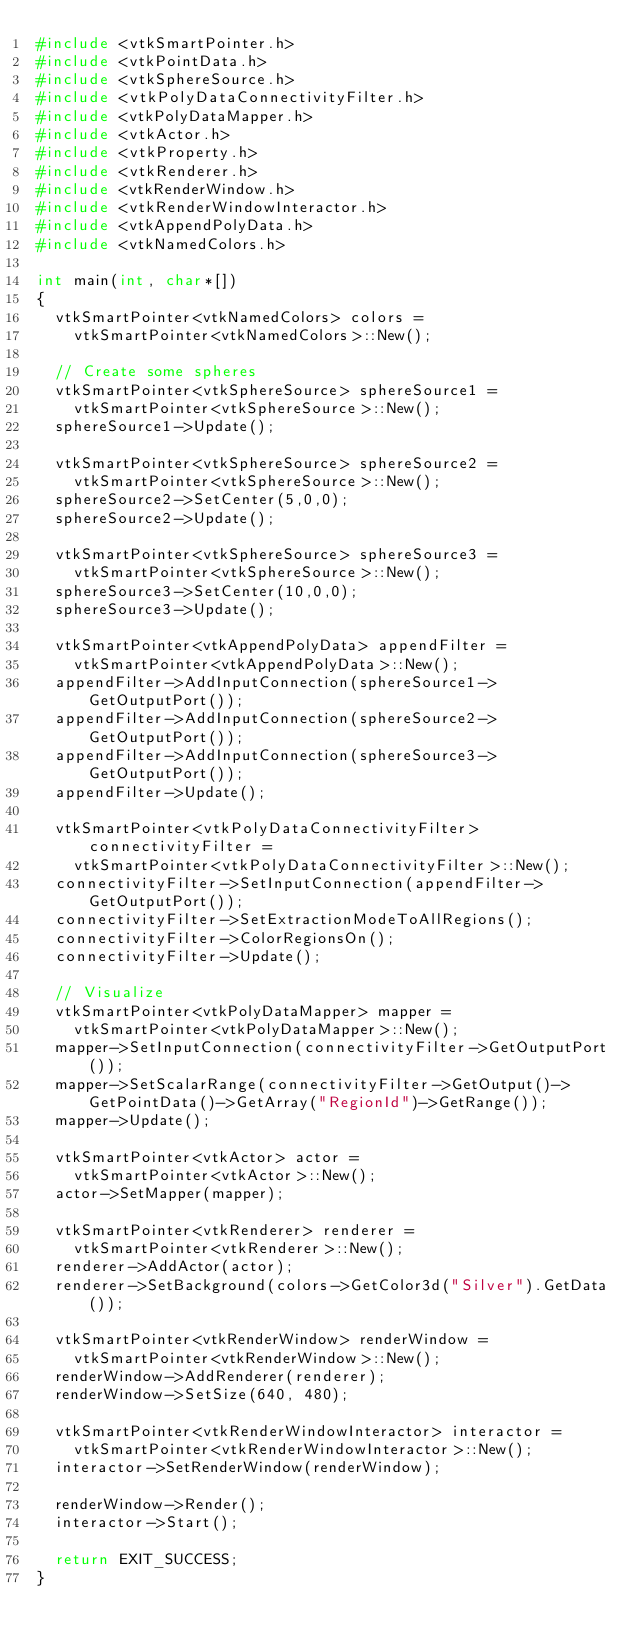Convert code to text. <code><loc_0><loc_0><loc_500><loc_500><_C++_>#include <vtkSmartPointer.h>
#include <vtkPointData.h>
#include <vtkSphereSource.h>
#include <vtkPolyDataConnectivityFilter.h>
#include <vtkPolyDataMapper.h>
#include <vtkActor.h>
#include <vtkProperty.h>
#include <vtkRenderer.h>
#include <vtkRenderWindow.h>
#include <vtkRenderWindowInteractor.h>
#include <vtkAppendPolyData.h>
#include <vtkNamedColors.h>

int main(int, char*[])
{
  vtkSmartPointer<vtkNamedColors> colors =
    vtkSmartPointer<vtkNamedColors>::New();

  // Create some spheres
  vtkSmartPointer<vtkSphereSource> sphereSource1 =
    vtkSmartPointer<vtkSphereSource>::New();
  sphereSource1->Update();

  vtkSmartPointer<vtkSphereSource> sphereSource2 =
    vtkSmartPointer<vtkSphereSource>::New();
  sphereSource2->SetCenter(5,0,0);
  sphereSource2->Update();

  vtkSmartPointer<vtkSphereSource> sphereSource3 =
    vtkSmartPointer<vtkSphereSource>::New();
  sphereSource3->SetCenter(10,0,0);
  sphereSource3->Update();

  vtkSmartPointer<vtkAppendPolyData> appendFilter =
    vtkSmartPointer<vtkAppendPolyData>::New();
  appendFilter->AddInputConnection(sphereSource1->GetOutputPort());
  appendFilter->AddInputConnection(sphereSource2->GetOutputPort());
  appendFilter->AddInputConnection(sphereSource3->GetOutputPort());
  appendFilter->Update();

  vtkSmartPointer<vtkPolyDataConnectivityFilter> connectivityFilter =
    vtkSmartPointer<vtkPolyDataConnectivityFilter>::New();
  connectivityFilter->SetInputConnection(appendFilter->GetOutputPort());
  connectivityFilter->SetExtractionModeToAllRegions();
  connectivityFilter->ColorRegionsOn();
  connectivityFilter->Update();

  // Visualize
  vtkSmartPointer<vtkPolyDataMapper> mapper =
    vtkSmartPointer<vtkPolyDataMapper>::New();
  mapper->SetInputConnection(connectivityFilter->GetOutputPort());
  mapper->SetScalarRange(connectivityFilter->GetOutput()->GetPointData()->GetArray("RegionId")->GetRange());
  mapper->Update();

  vtkSmartPointer<vtkActor> actor =
    vtkSmartPointer<vtkActor>::New();
  actor->SetMapper(mapper);

  vtkSmartPointer<vtkRenderer> renderer =
    vtkSmartPointer<vtkRenderer>::New();
  renderer->AddActor(actor);
  renderer->SetBackground(colors->GetColor3d("Silver").GetData());

  vtkSmartPointer<vtkRenderWindow> renderWindow =
    vtkSmartPointer<vtkRenderWindow>::New();
  renderWindow->AddRenderer(renderer);
  renderWindow->SetSize(640, 480);

  vtkSmartPointer<vtkRenderWindowInteractor> interactor =
    vtkSmartPointer<vtkRenderWindowInteractor>::New();
  interactor->SetRenderWindow(renderWindow);

  renderWindow->Render();
  interactor->Start();

  return EXIT_SUCCESS;
}
</code> 